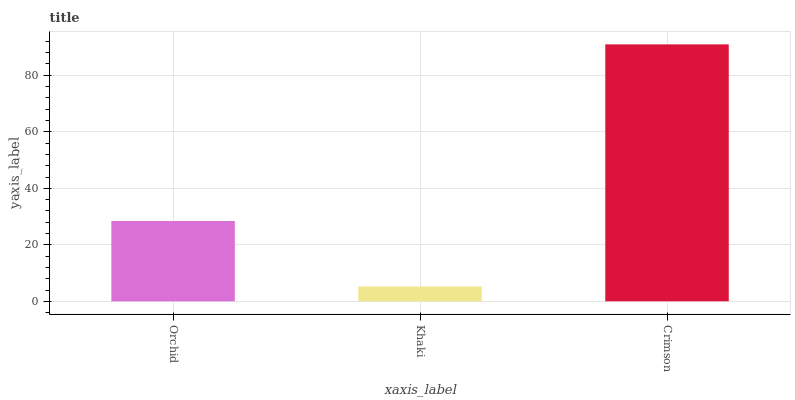Is Khaki the minimum?
Answer yes or no. Yes. Is Crimson the maximum?
Answer yes or no. Yes. Is Crimson the minimum?
Answer yes or no. No. Is Khaki the maximum?
Answer yes or no. No. Is Crimson greater than Khaki?
Answer yes or no. Yes. Is Khaki less than Crimson?
Answer yes or no. Yes. Is Khaki greater than Crimson?
Answer yes or no. No. Is Crimson less than Khaki?
Answer yes or no. No. Is Orchid the high median?
Answer yes or no. Yes. Is Orchid the low median?
Answer yes or no. Yes. Is Crimson the high median?
Answer yes or no. No. Is Crimson the low median?
Answer yes or no. No. 